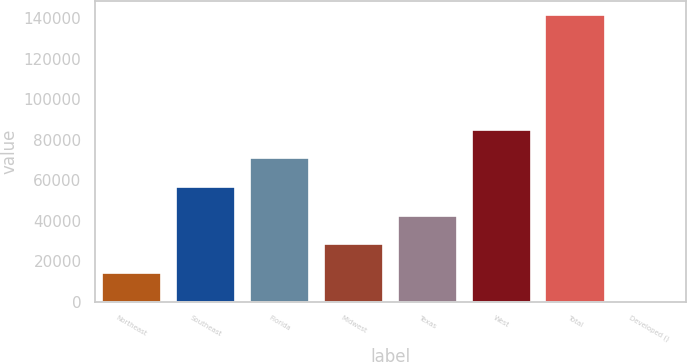<chart> <loc_0><loc_0><loc_500><loc_500><bar_chart><fcel>Northeast<fcel>Southeast<fcel>Florida<fcel>Midwest<fcel>Texas<fcel>West<fcel>Total<fcel>Developed ()<nl><fcel>14168.8<fcel>56582.2<fcel>70720<fcel>28306.6<fcel>42444.4<fcel>84857.8<fcel>141409<fcel>31<nl></chart> 